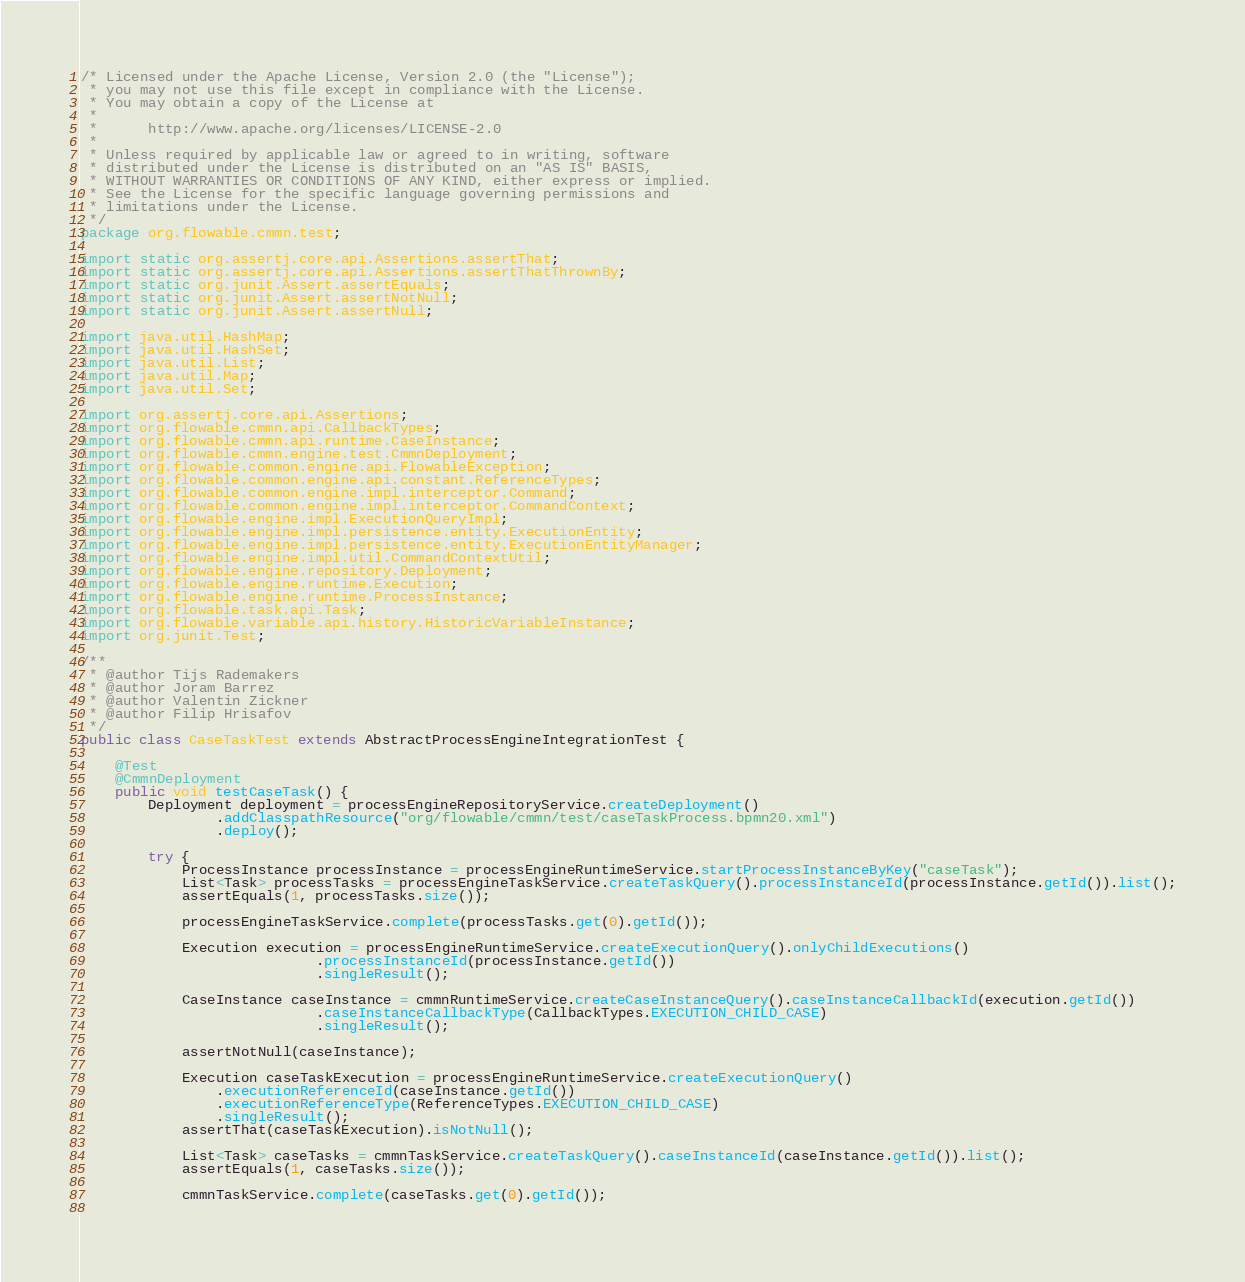<code> <loc_0><loc_0><loc_500><loc_500><_Java_>/* Licensed under the Apache License, Version 2.0 (the "License");
 * you may not use this file except in compliance with the License.
 * You may obtain a copy of the License at
 *
 *      http://www.apache.org/licenses/LICENSE-2.0
 *
 * Unless required by applicable law or agreed to in writing, software
 * distributed under the License is distributed on an "AS IS" BASIS,
 * WITHOUT WARRANTIES OR CONDITIONS OF ANY KIND, either express or implied.
 * See the License for the specific language governing permissions and
 * limitations under the License.
 */
package org.flowable.cmmn.test;

import static org.assertj.core.api.Assertions.assertThat;
import static org.assertj.core.api.Assertions.assertThatThrownBy;
import static org.junit.Assert.assertEquals;
import static org.junit.Assert.assertNotNull;
import static org.junit.Assert.assertNull;

import java.util.HashMap;
import java.util.HashSet;
import java.util.List;
import java.util.Map;
import java.util.Set;

import org.assertj.core.api.Assertions;
import org.flowable.cmmn.api.CallbackTypes;
import org.flowable.cmmn.api.runtime.CaseInstance;
import org.flowable.cmmn.engine.test.CmmnDeployment;
import org.flowable.common.engine.api.FlowableException;
import org.flowable.common.engine.api.constant.ReferenceTypes;
import org.flowable.common.engine.impl.interceptor.Command;
import org.flowable.common.engine.impl.interceptor.CommandContext;
import org.flowable.engine.impl.ExecutionQueryImpl;
import org.flowable.engine.impl.persistence.entity.ExecutionEntity;
import org.flowable.engine.impl.persistence.entity.ExecutionEntityManager;
import org.flowable.engine.impl.util.CommandContextUtil;
import org.flowable.engine.repository.Deployment;
import org.flowable.engine.runtime.Execution;
import org.flowable.engine.runtime.ProcessInstance;
import org.flowable.task.api.Task;
import org.flowable.variable.api.history.HistoricVariableInstance;
import org.junit.Test;

/**
 * @author Tijs Rademakers
 * @author Joram Barrez
 * @author Valentin Zickner
 * @author Filip Hrisafov
 */
public class CaseTaskTest extends AbstractProcessEngineIntegrationTest {
    
    @Test
    @CmmnDeployment
    public void testCaseTask() {
        Deployment deployment = processEngineRepositoryService.createDeployment()
                .addClasspathResource("org/flowable/cmmn/test/caseTaskProcess.bpmn20.xml")
                .deploy();
        
        try {
            ProcessInstance processInstance = processEngineRuntimeService.startProcessInstanceByKey("caseTask");
            List<Task> processTasks = processEngineTaskService.createTaskQuery().processInstanceId(processInstance.getId()).list();
            assertEquals(1, processTasks.size());
            
            processEngineTaskService.complete(processTasks.get(0).getId());
            
            Execution execution = processEngineRuntimeService.createExecutionQuery().onlyChildExecutions()
                            .processInstanceId(processInstance.getId())
                            .singleResult();
            
            CaseInstance caseInstance = cmmnRuntimeService.createCaseInstanceQuery().caseInstanceCallbackId(execution.getId())
                            .caseInstanceCallbackType(CallbackTypes.EXECUTION_CHILD_CASE)
                            .singleResult();
            
            assertNotNull(caseInstance);

            Execution caseTaskExecution = processEngineRuntimeService.createExecutionQuery()
                .executionReferenceId(caseInstance.getId())
                .executionReferenceType(ReferenceTypes.EXECUTION_CHILD_CASE)
                .singleResult();
            assertThat(caseTaskExecution).isNotNull();

            List<Task> caseTasks = cmmnTaskService.createTaskQuery().caseInstanceId(caseInstance.getId()).list();
            assertEquals(1, caseTasks.size());
            
            cmmnTaskService.complete(caseTasks.get(0).getId());
            </code> 